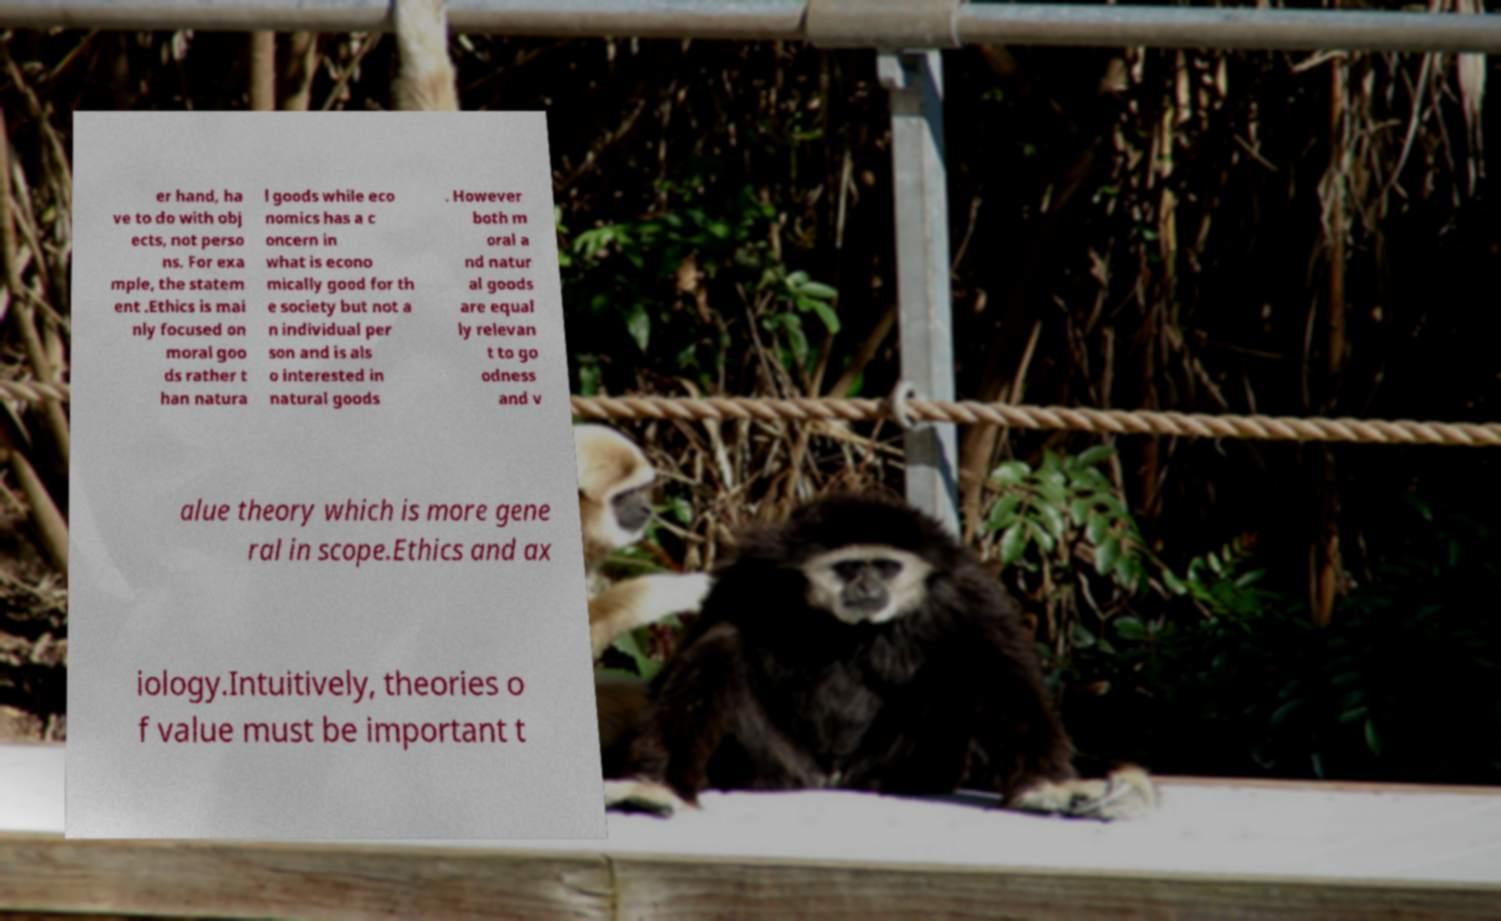Can you read and provide the text displayed in the image?This photo seems to have some interesting text. Can you extract and type it out for me? er hand, ha ve to do with obj ects, not perso ns. For exa mple, the statem ent .Ethics is mai nly focused on moral goo ds rather t han natura l goods while eco nomics has a c oncern in what is econo mically good for th e society but not a n individual per son and is als o interested in natural goods . However both m oral a nd natur al goods are equal ly relevan t to go odness and v alue theory which is more gene ral in scope.Ethics and ax iology.Intuitively, theories o f value must be important t 